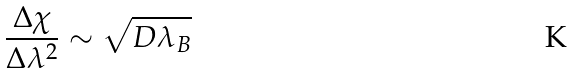<formula> <loc_0><loc_0><loc_500><loc_500>\frac { \Delta \chi } { \Delta \lambda ^ { 2 } } \sim \sqrt { D \lambda _ { B } }</formula> 